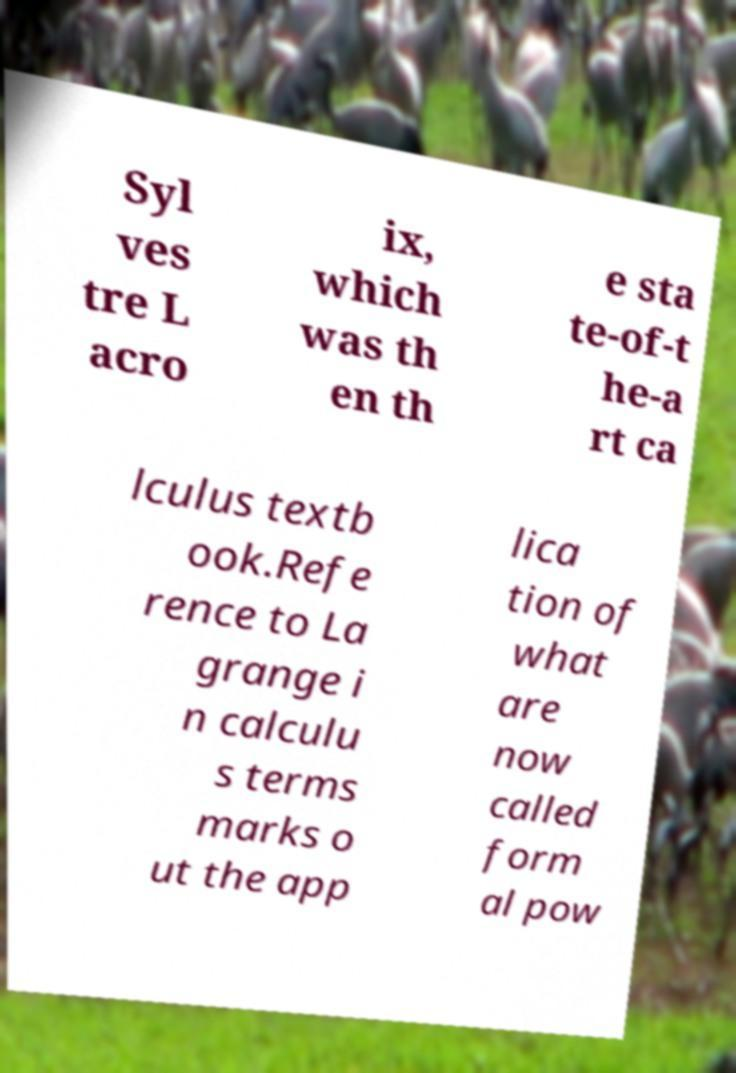Please read and relay the text visible in this image. What does it say? Syl ves tre L acro ix, which was th en th e sta te-of-t he-a rt ca lculus textb ook.Refe rence to La grange i n calculu s terms marks o ut the app lica tion of what are now called form al pow 